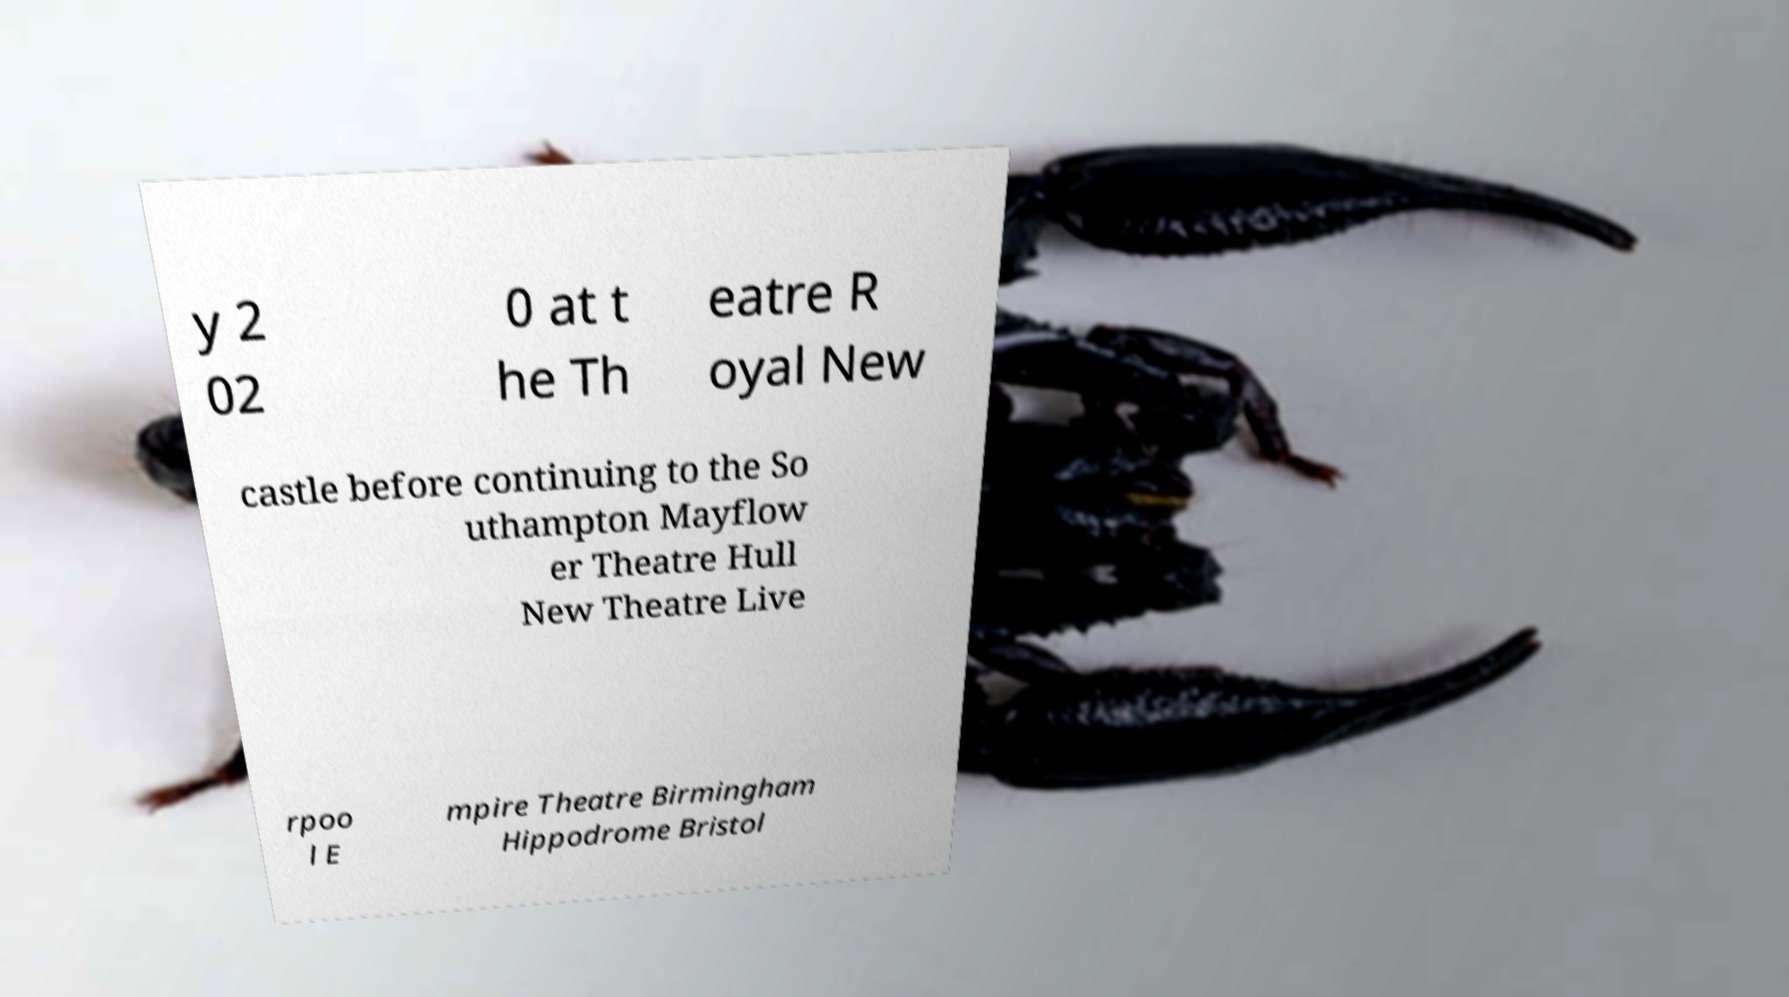Could you extract and type out the text from this image? y 2 02 0 at t he Th eatre R oyal New castle before continuing to the So uthampton Mayflow er Theatre Hull New Theatre Live rpoo l E mpire Theatre Birmingham Hippodrome Bristol 